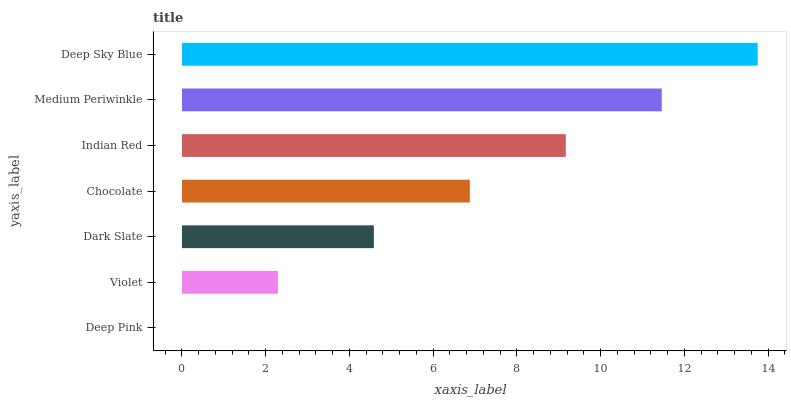Is Deep Pink the minimum?
Answer yes or no. Yes. Is Deep Sky Blue the maximum?
Answer yes or no. Yes. Is Violet the minimum?
Answer yes or no. No. Is Violet the maximum?
Answer yes or no. No. Is Violet greater than Deep Pink?
Answer yes or no. Yes. Is Deep Pink less than Violet?
Answer yes or no. Yes. Is Deep Pink greater than Violet?
Answer yes or no. No. Is Violet less than Deep Pink?
Answer yes or no. No. Is Chocolate the high median?
Answer yes or no. Yes. Is Chocolate the low median?
Answer yes or no. Yes. Is Dark Slate the high median?
Answer yes or no. No. Is Violet the low median?
Answer yes or no. No. 